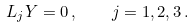<formula> <loc_0><loc_0><loc_500><loc_500>L _ { j } Y = 0 \, , \quad j = 1 , 2 , 3 \, .</formula> 